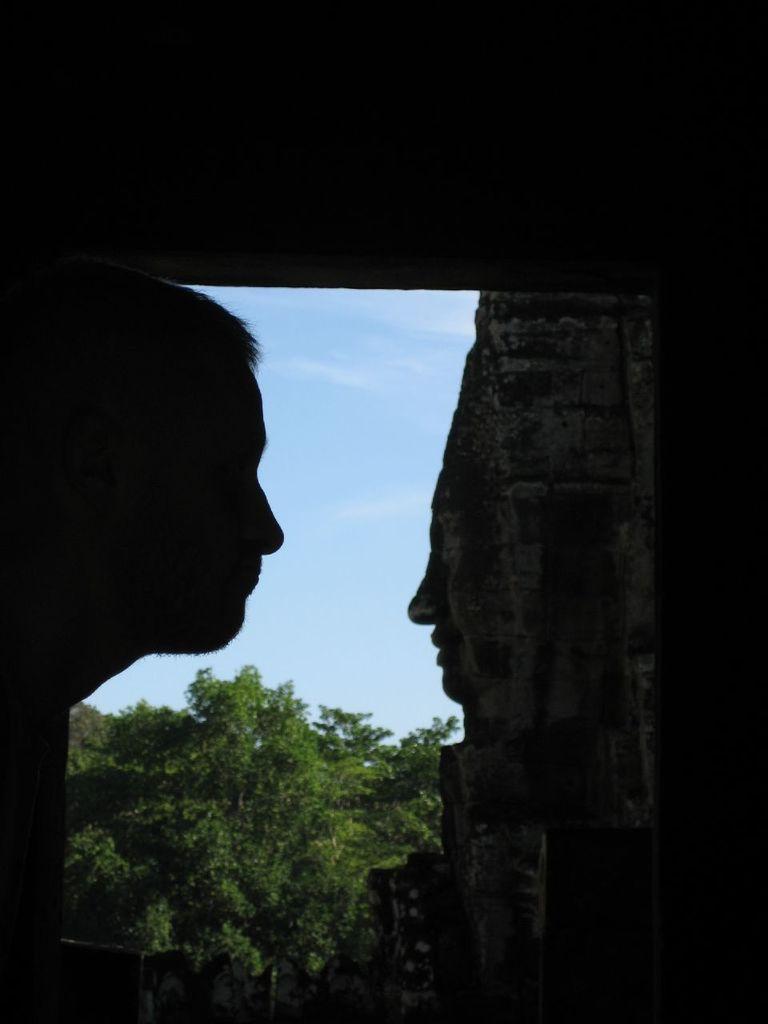Please provide a concise description of this image. On the right side of the image, we can see a person's head. On the right side, there is a stone carving. Background there are few trees and sky. 